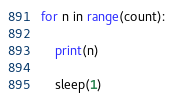<code> <loc_0><loc_0><loc_500><loc_500><_Python_>for n in range(count):

    print(n)

    sleep(1)</code> 